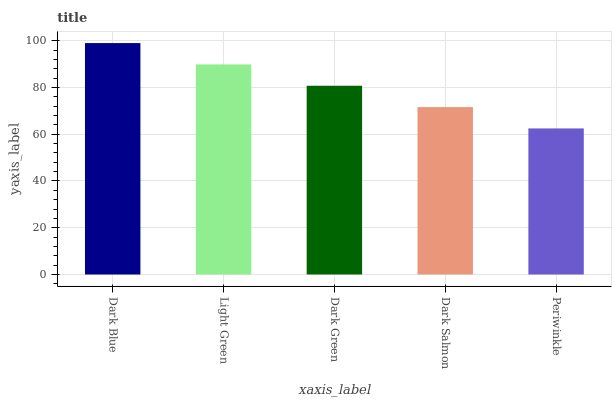Is Periwinkle the minimum?
Answer yes or no. Yes. Is Dark Blue the maximum?
Answer yes or no. Yes. Is Light Green the minimum?
Answer yes or no. No. Is Light Green the maximum?
Answer yes or no. No. Is Dark Blue greater than Light Green?
Answer yes or no. Yes. Is Light Green less than Dark Blue?
Answer yes or no. Yes. Is Light Green greater than Dark Blue?
Answer yes or no. No. Is Dark Blue less than Light Green?
Answer yes or no. No. Is Dark Green the high median?
Answer yes or no. Yes. Is Dark Green the low median?
Answer yes or no. Yes. Is Light Green the high median?
Answer yes or no. No. Is Dark Blue the low median?
Answer yes or no. No. 